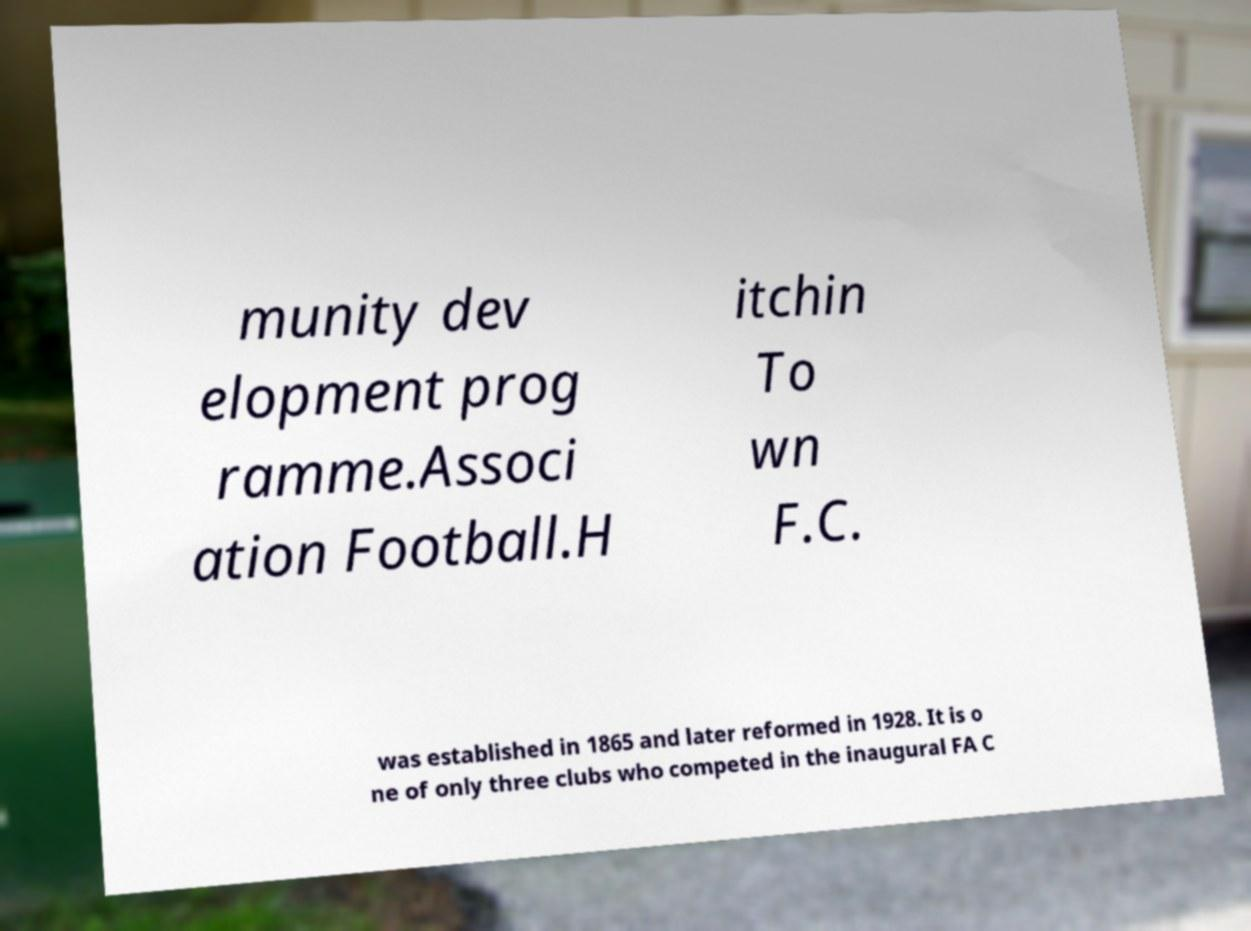Could you assist in decoding the text presented in this image and type it out clearly? munity dev elopment prog ramme.Associ ation Football.H itchin To wn F.C. was established in 1865 and later reformed in 1928. It is o ne of only three clubs who competed in the inaugural FA C 